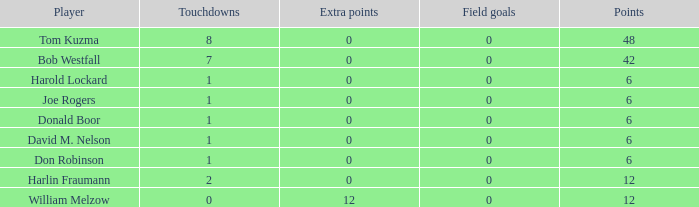Name the least touchdowns for joe rogers 1.0. 